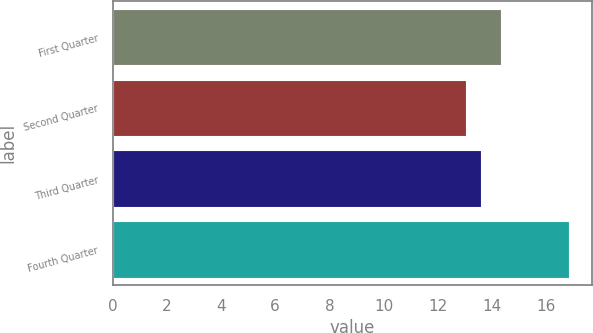Convert chart to OTSL. <chart><loc_0><loc_0><loc_500><loc_500><bar_chart><fcel>First Quarter<fcel>Second Quarter<fcel>Third Quarter<fcel>Fourth Quarter<nl><fcel>14.34<fcel>13.05<fcel>13.6<fcel>16.85<nl></chart> 